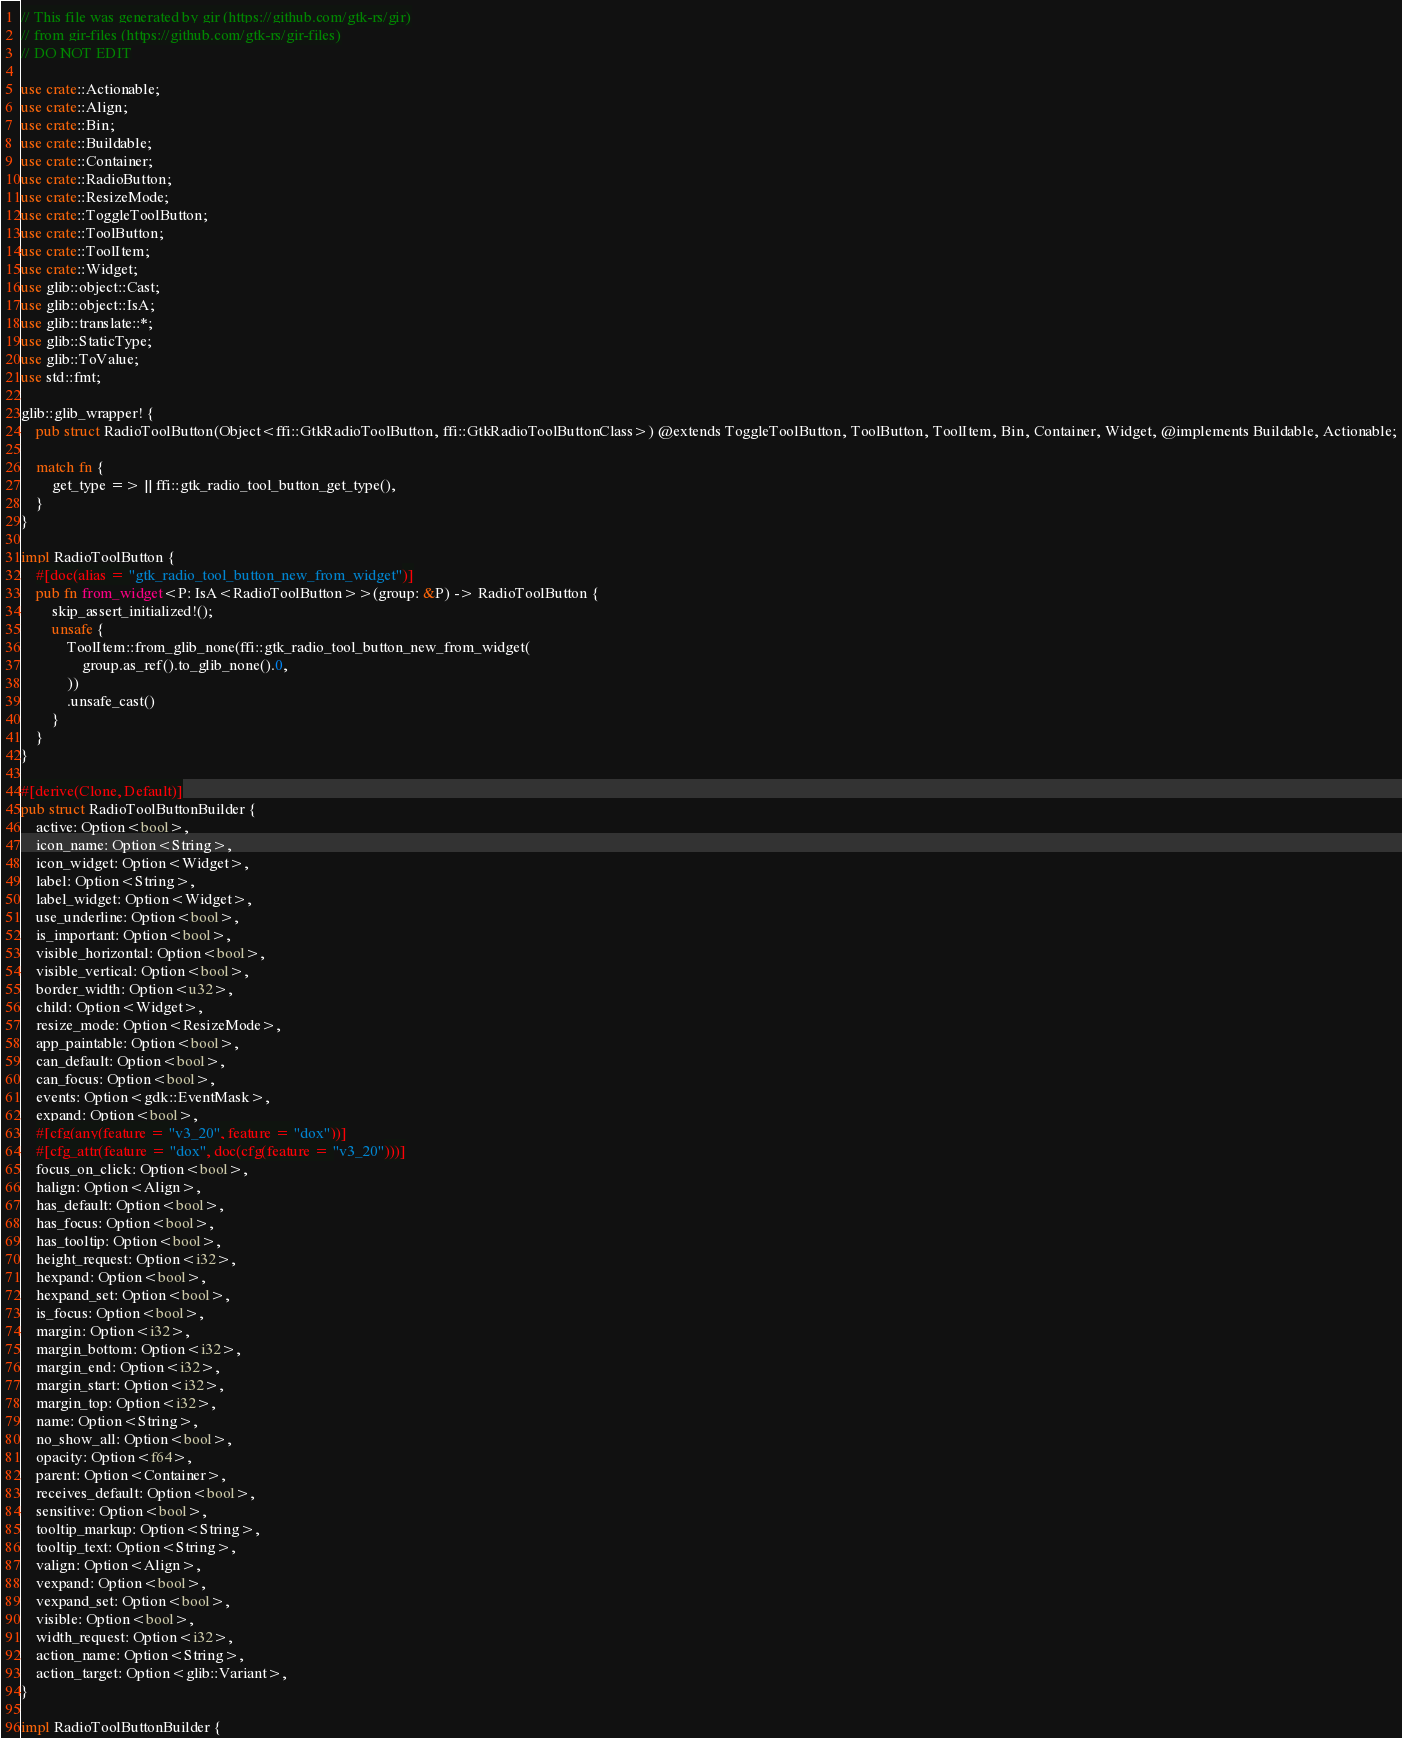<code> <loc_0><loc_0><loc_500><loc_500><_Rust_>// This file was generated by gir (https://github.com/gtk-rs/gir)
// from gir-files (https://github.com/gtk-rs/gir-files)
// DO NOT EDIT

use crate::Actionable;
use crate::Align;
use crate::Bin;
use crate::Buildable;
use crate::Container;
use crate::RadioButton;
use crate::ResizeMode;
use crate::ToggleToolButton;
use crate::ToolButton;
use crate::ToolItem;
use crate::Widget;
use glib::object::Cast;
use glib::object::IsA;
use glib::translate::*;
use glib::StaticType;
use glib::ToValue;
use std::fmt;

glib::glib_wrapper! {
    pub struct RadioToolButton(Object<ffi::GtkRadioToolButton, ffi::GtkRadioToolButtonClass>) @extends ToggleToolButton, ToolButton, ToolItem, Bin, Container, Widget, @implements Buildable, Actionable;

    match fn {
        get_type => || ffi::gtk_radio_tool_button_get_type(),
    }
}

impl RadioToolButton {
    #[doc(alias = "gtk_radio_tool_button_new_from_widget")]
    pub fn from_widget<P: IsA<RadioToolButton>>(group: &P) -> RadioToolButton {
        skip_assert_initialized!();
        unsafe {
            ToolItem::from_glib_none(ffi::gtk_radio_tool_button_new_from_widget(
                group.as_ref().to_glib_none().0,
            ))
            .unsafe_cast()
        }
    }
}

#[derive(Clone, Default)]
pub struct RadioToolButtonBuilder {
    active: Option<bool>,
    icon_name: Option<String>,
    icon_widget: Option<Widget>,
    label: Option<String>,
    label_widget: Option<Widget>,
    use_underline: Option<bool>,
    is_important: Option<bool>,
    visible_horizontal: Option<bool>,
    visible_vertical: Option<bool>,
    border_width: Option<u32>,
    child: Option<Widget>,
    resize_mode: Option<ResizeMode>,
    app_paintable: Option<bool>,
    can_default: Option<bool>,
    can_focus: Option<bool>,
    events: Option<gdk::EventMask>,
    expand: Option<bool>,
    #[cfg(any(feature = "v3_20", feature = "dox"))]
    #[cfg_attr(feature = "dox", doc(cfg(feature = "v3_20")))]
    focus_on_click: Option<bool>,
    halign: Option<Align>,
    has_default: Option<bool>,
    has_focus: Option<bool>,
    has_tooltip: Option<bool>,
    height_request: Option<i32>,
    hexpand: Option<bool>,
    hexpand_set: Option<bool>,
    is_focus: Option<bool>,
    margin: Option<i32>,
    margin_bottom: Option<i32>,
    margin_end: Option<i32>,
    margin_start: Option<i32>,
    margin_top: Option<i32>,
    name: Option<String>,
    no_show_all: Option<bool>,
    opacity: Option<f64>,
    parent: Option<Container>,
    receives_default: Option<bool>,
    sensitive: Option<bool>,
    tooltip_markup: Option<String>,
    tooltip_text: Option<String>,
    valign: Option<Align>,
    vexpand: Option<bool>,
    vexpand_set: Option<bool>,
    visible: Option<bool>,
    width_request: Option<i32>,
    action_name: Option<String>,
    action_target: Option<glib::Variant>,
}

impl RadioToolButtonBuilder {</code> 